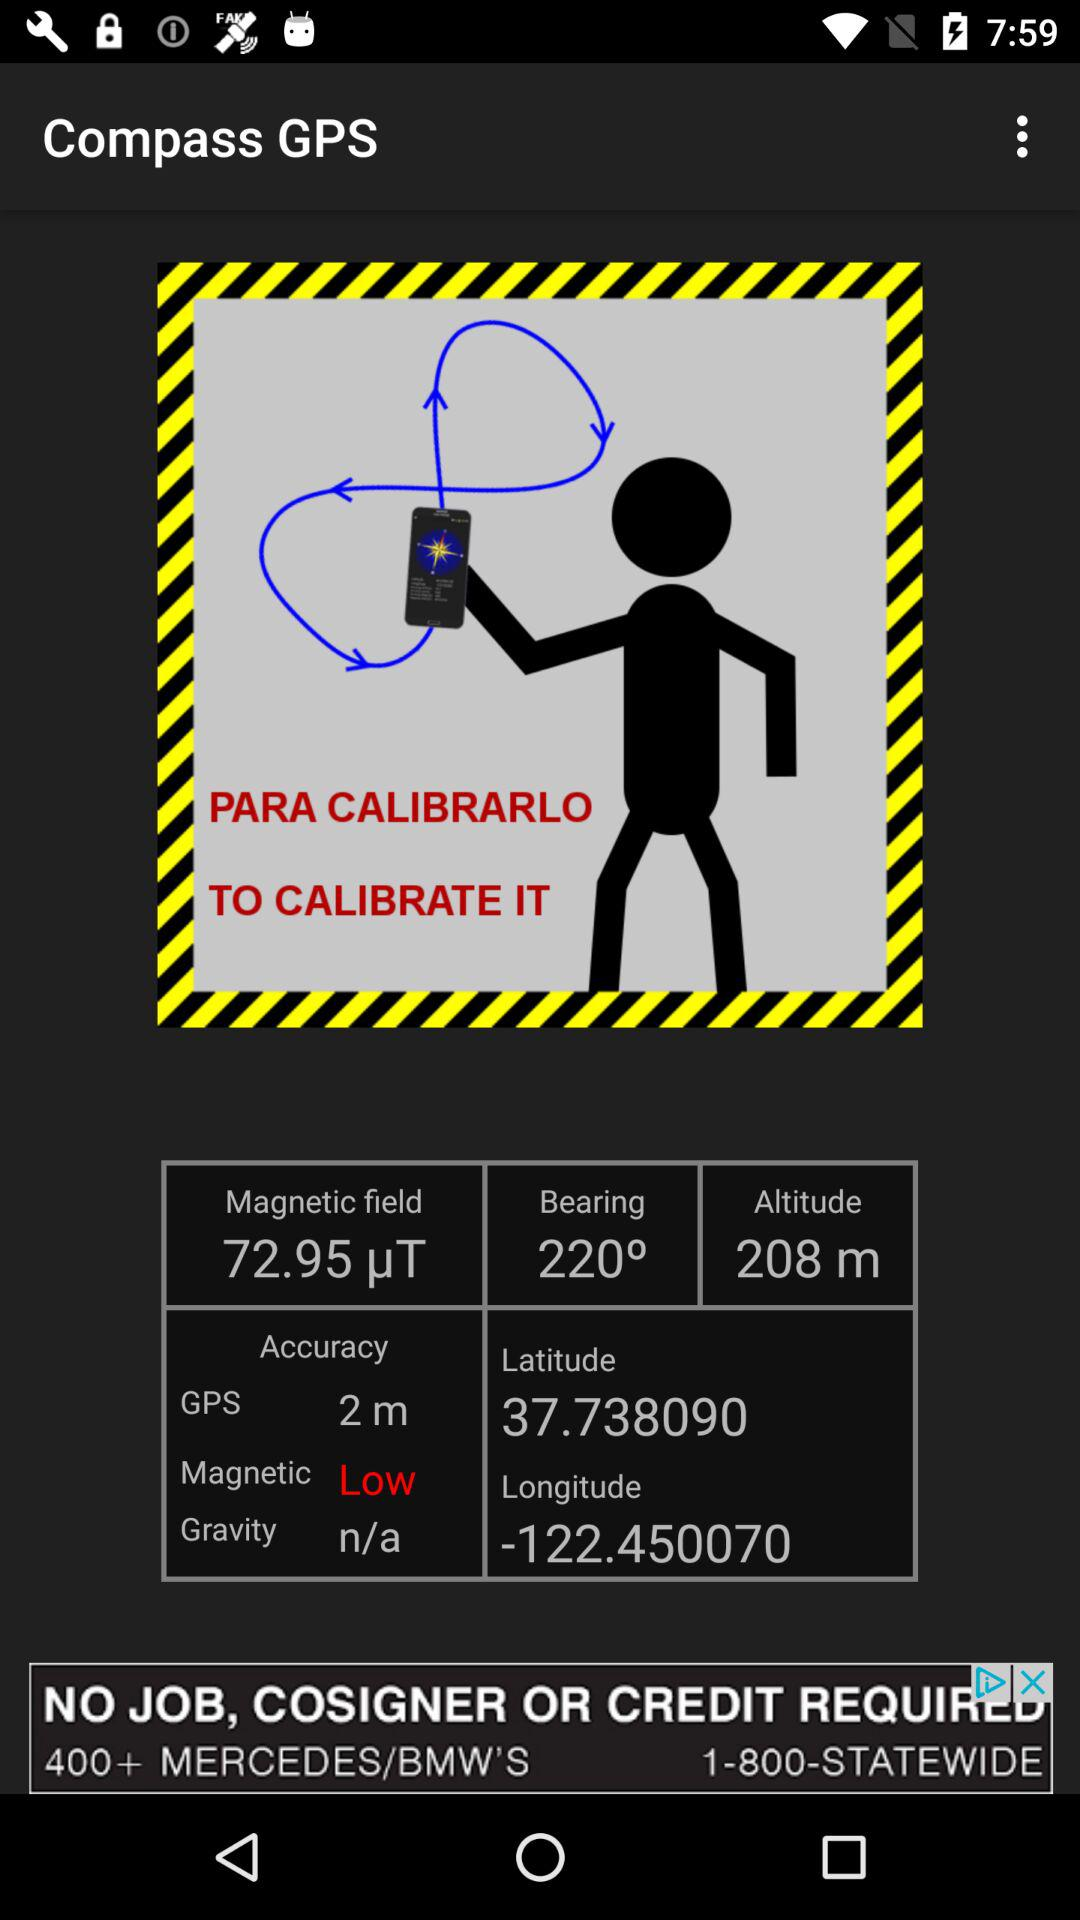How many degrees is the compass pointing?
Answer the question using a single word or phrase. 219° 